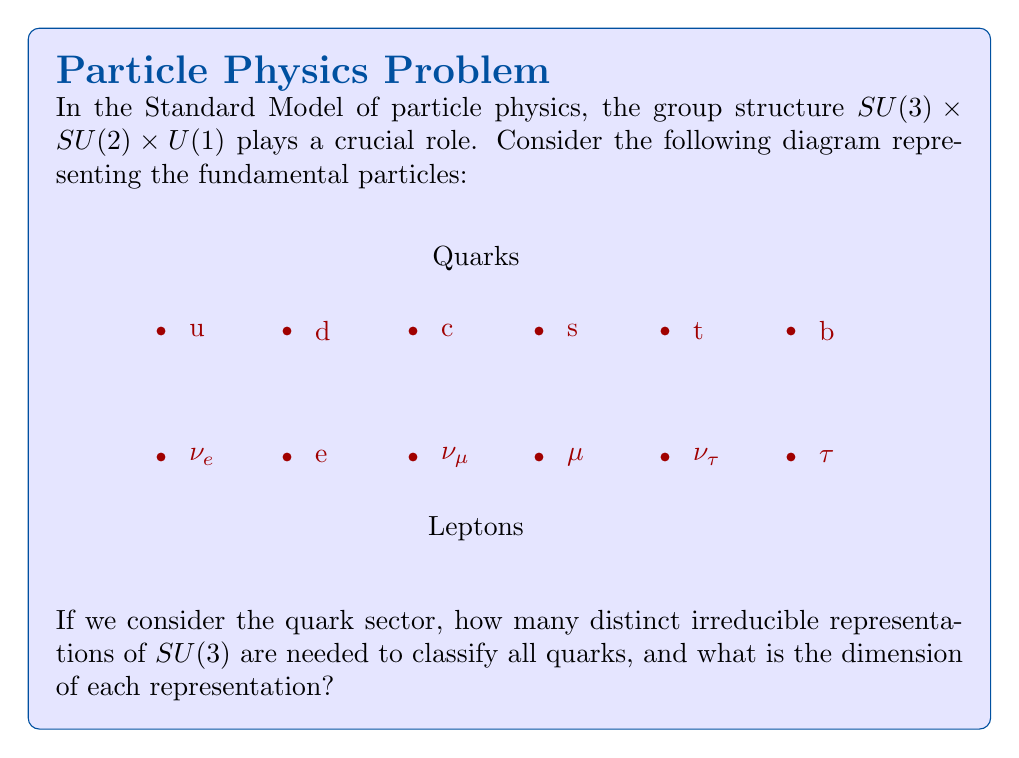What is the answer to this math problem? To answer this question, we need to analyze the quark sector in the Standard Model:

1) In the Standard Model, quarks come in six "flavors": up (u), down (d), charm (c), strange (s), top (t), and bottom (b).

2) Quarks are classified according to their color charge, which is a property described by the $SU(3)$ group of Quantum Chromodynamics (QCD).

3) Each quark flavor can exist in three color states: red, green, or blue. This means that each quark flavor transforms as a fundamental representation of $SU(3)$.

4) The fundamental representation of $SU(3)$ is three-dimensional, denoted as $\mathbf{3}$.

5) All six quark flavors transform in the same way under $SU(3)$. They all belong to the same type of representation.

6) Therefore, we only need one type of irreducible representation to classify all quarks under $SU(3)$, which is the fundamental representation $\mathbf{3}$.

7) The dimension of this representation is 3, corresponding to the three color states.

Thus, we need only one distinct irreducible representation of $SU(3)$ to classify all quarks, and this representation has dimension 3.
Answer: 1 representation, dimension 3 